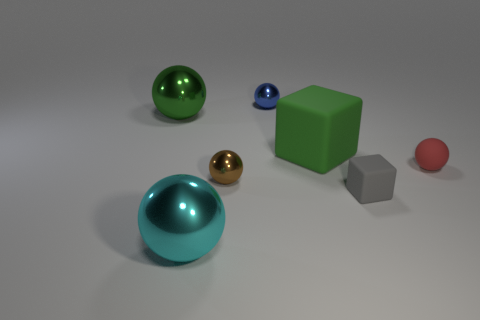Subtract all large green metallic balls. How many balls are left? 4 Add 3 small green balls. How many objects exist? 10 Subtract all blue balls. How many balls are left? 4 Subtract all balls. How many objects are left? 2 Subtract all green matte blocks. Subtract all green metallic balls. How many objects are left? 5 Add 5 brown objects. How many brown objects are left? 6 Add 3 rubber spheres. How many rubber spheres exist? 4 Subtract 0 green cylinders. How many objects are left? 7 Subtract all red spheres. Subtract all green cylinders. How many spheres are left? 4 